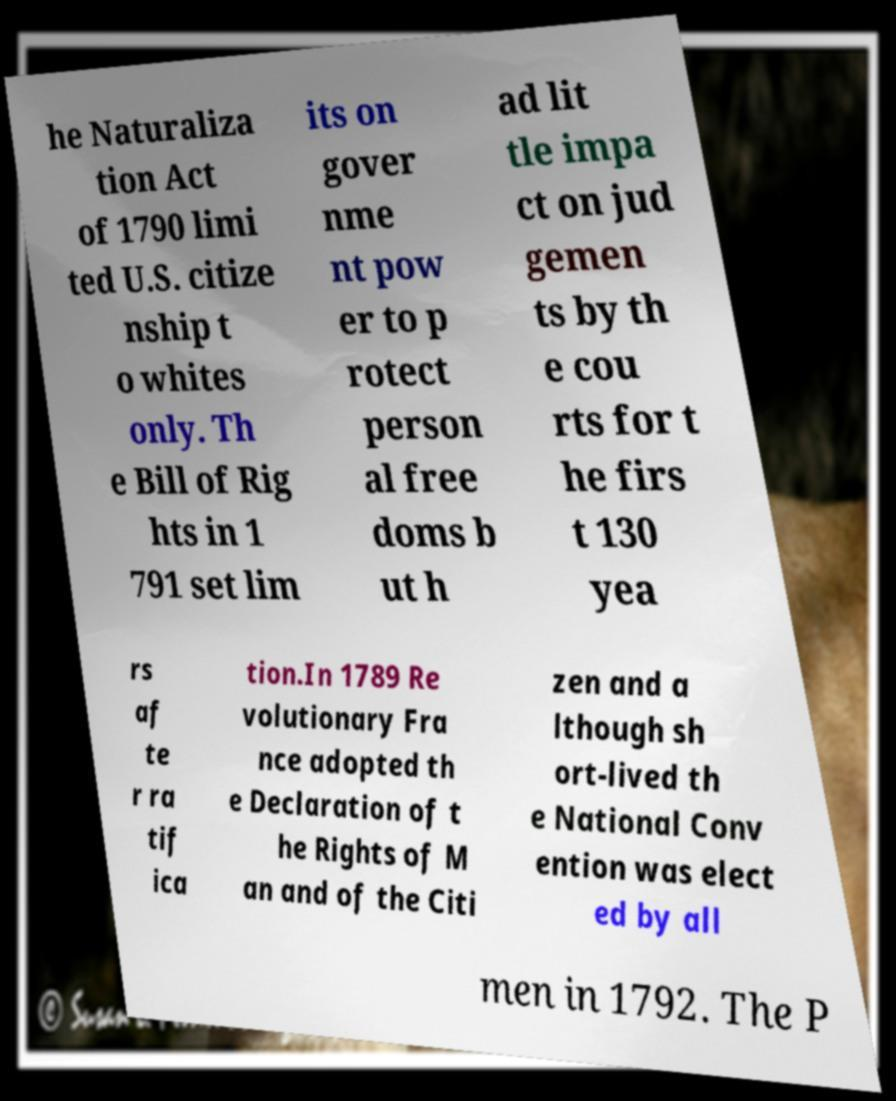Can you read and provide the text displayed in the image?This photo seems to have some interesting text. Can you extract and type it out for me? he Naturaliza tion Act of 1790 limi ted U.S. citize nship t o whites only. Th e Bill of Rig hts in 1 791 set lim its on gover nme nt pow er to p rotect person al free doms b ut h ad lit tle impa ct on jud gemen ts by th e cou rts for t he firs t 130 yea rs af te r ra tif ica tion.In 1789 Re volutionary Fra nce adopted th e Declaration of t he Rights of M an and of the Citi zen and a lthough sh ort-lived th e National Conv ention was elect ed by all men in 1792. The P 